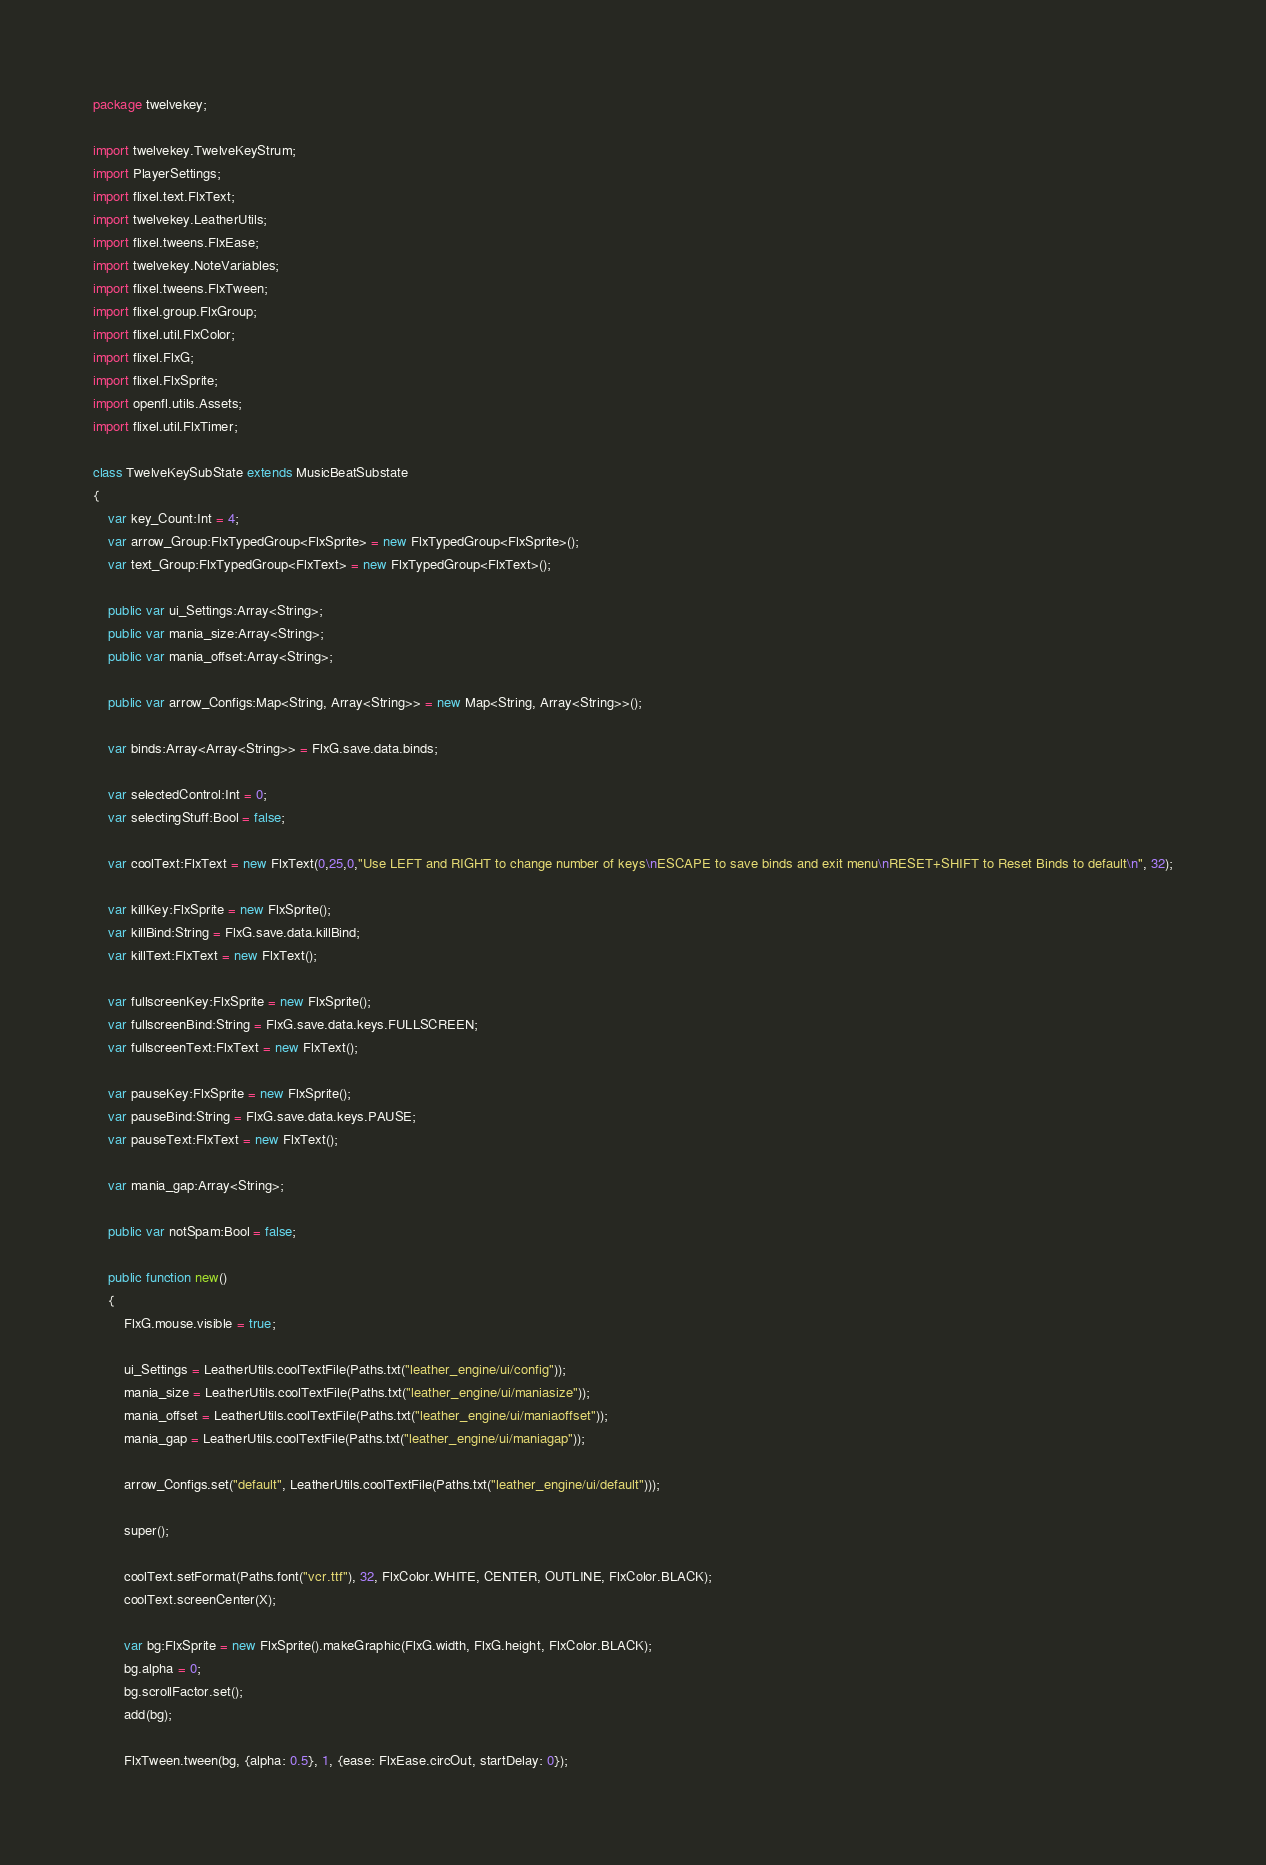Convert code to text. <code><loc_0><loc_0><loc_500><loc_500><_Haxe_>package twelvekey;

import twelvekey.TwelveKeyStrum;
import PlayerSettings;
import flixel.text.FlxText;
import twelvekey.LeatherUtils;
import flixel.tweens.FlxEase;
import twelvekey.NoteVariables;
import flixel.tweens.FlxTween;
import flixel.group.FlxGroup;
import flixel.util.FlxColor;
import flixel.FlxG;
import flixel.FlxSprite;
import openfl.utils.Assets;
import flixel.util.FlxTimer;

class TwelveKeySubState extends MusicBeatSubstate
{
    var key_Count:Int = 4;
    var arrow_Group:FlxTypedGroup<FlxSprite> = new FlxTypedGroup<FlxSprite>();
    var text_Group:FlxTypedGroup<FlxText> = new FlxTypedGroup<FlxText>();

    public var ui_Settings:Array<String>;
    public var mania_size:Array<String>;
    public var mania_offset:Array<String>;

    public var arrow_Configs:Map<String, Array<String>> = new Map<String, Array<String>>();

    var binds:Array<Array<String>> = FlxG.save.data.binds;

    var selectedControl:Int = 0;
    var selectingStuff:Bool = false;

    var coolText:FlxText = new FlxText(0,25,0,"Use LEFT and RIGHT to change number of keys\nESCAPE to save binds and exit menu\nRESET+SHIFT to Reset Binds to default\n", 32);

    var killKey:FlxSprite = new FlxSprite();
    var killBind:String = FlxG.save.data.killBind;
    var killText:FlxText = new FlxText();

    var fullscreenKey:FlxSprite = new FlxSprite();
    var fullscreenBind:String = FlxG.save.data.keys.FULLSCREEN;
    var fullscreenText:FlxText = new FlxText();

    var pauseKey:FlxSprite = new FlxSprite();
    var pauseBind:String = FlxG.save.data.keys.PAUSE;
    var pauseText:FlxText = new FlxText();

    var mania_gap:Array<String>;

    public var notSpam:Bool = false;

    public function new()
    {
        FlxG.mouse.visible = true;

        ui_Settings = LeatherUtils.coolTextFile(Paths.txt("leather_engine/ui/config"));
        mania_size = LeatherUtils.coolTextFile(Paths.txt("leather_engine/ui/maniasize"));
        mania_offset = LeatherUtils.coolTextFile(Paths.txt("leather_engine/ui/maniaoffset"));
        mania_gap = LeatherUtils.coolTextFile(Paths.txt("leather_engine/ui/maniagap"));

        arrow_Configs.set("default", LeatherUtils.coolTextFile(Paths.txt("leather_engine/ui/default")));

        super();

        coolText.setFormat(Paths.font("vcr.ttf"), 32, FlxColor.WHITE, CENTER, OUTLINE, FlxColor.BLACK);
        coolText.screenCenter(X);
        
        var bg:FlxSprite = new FlxSprite().makeGraphic(FlxG.width, FlxG.height, FlxColor.BLACK);
        bg.alpha = 0;
        bg.scrollFactor.set();
        add(bg);

        FlxTween.tween(bg, {alpha: 0.5}, 1, {ease: FlxEase.circOut, startDelay: 0});
</code> 